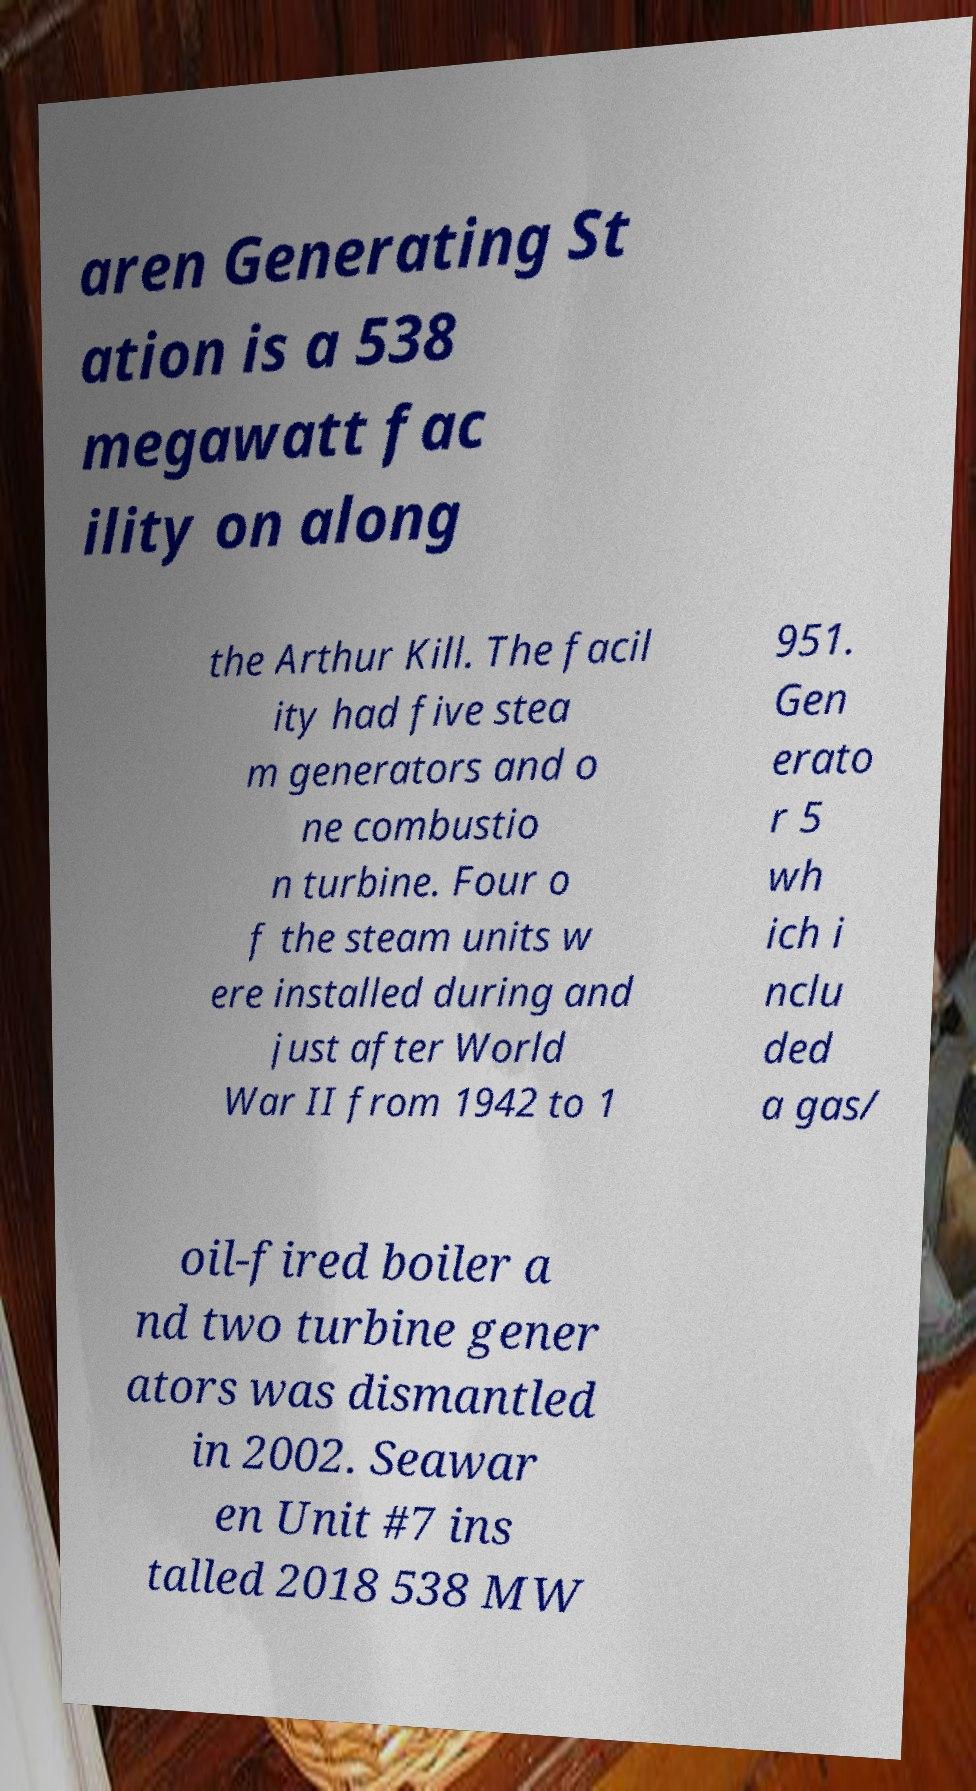Please read and relay the text visible in this image. What does it say? aren Generating St ation is a 538 megawatt fac ility on along the Arthur Kill. The facil ity had five stea m generators and o ne combustio n turbine. Four o f the steam units w ere installed during and just after World War II from 1942 to 1 951. Gen erato r 5 wh ich i nclu ded a gas/ oil-fired boiler a nd two turbine gener ators was dismantled in 2002. Seawar en Unit #7 ins talled 2018 538 MW 